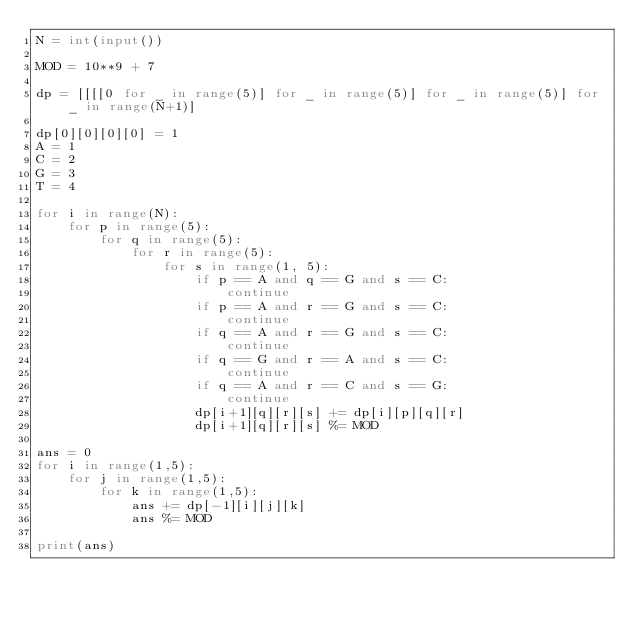Convert code to text. <code><loc_0><loc_0><loc_500><loc_500><_Python_>N = int(input())

MOD = 10**9 + 7

dp = [[[[0 for _ in range(5)] for _ in range(5)] for _ in range(5)] for _ in range(N+1)]

dp[0][0][0][0] = 1
A = 1
C = 2
G = 3
T = 4

for i in range(N):
    for p in range(5):
        for q in range(5):
            for r in range(5):
                for s in range(1, 5):
                    if p == A and q == G and s == C: 
                        continue
                    if p == A and r == G and s == C:
                        continue
                    if q == A and r == G and s == C: 
                        continue
                    if q == G and r == A and s == C:
                        continue
                    if q == A and r == C and s == G: 
                        continue
                    dp[i+1][q][r][s] += dp[i][p][q][r]
                    dp[i+1][q][r][s] %= MOD

ans = 0
for i in range(1,5):
    for j in range(1,5):
        for k in range(1,5):
            ans += dp[-1][i][j][k]
            ans %= MOD

print(ans) </code> 